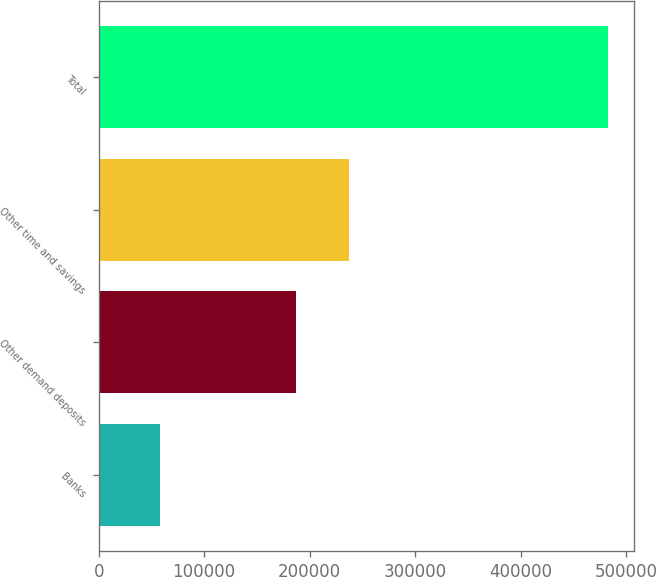<chart> <loc_0><loc_0><loc_500><loc_500><bar_chart><fcel>Banks<fcel>Other demand deposits<fcel>Other time and savings<fcel>Total<nl><fcel>58046<fcel>187478<fcel>237653<fcel>483177<nl></chart> 